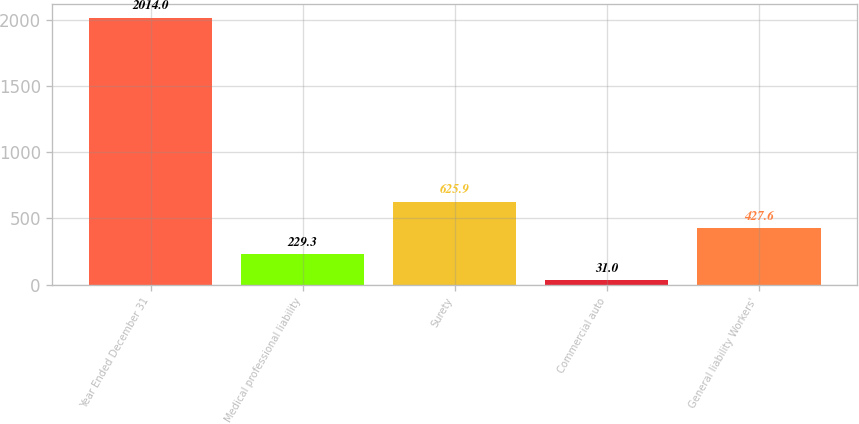Convert chart. <chart><loc_0><loc_0><loc_500><loc_500><bar_chart><fcel>Year Ended December 31<fcel>Medical professional liability<fcel>Surety<fcel>Commercial auto<fcel>General liability Workers'<nl><fcel>2014<fcel>229.3<fcel>625.9<fcel>31<fcel>427.6<nl></chart> 